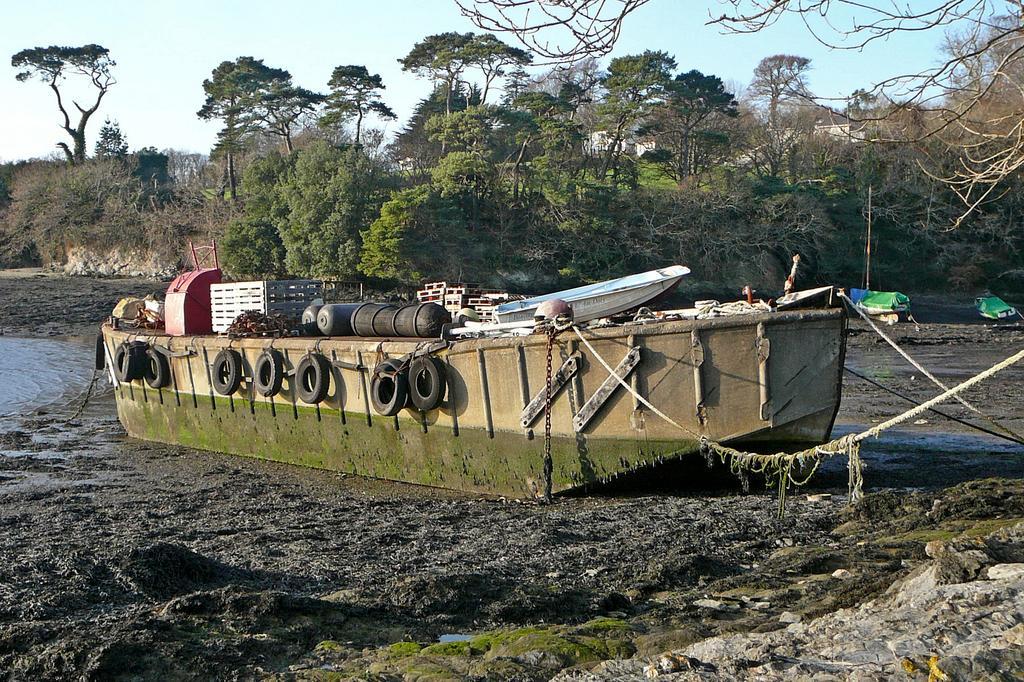Describe this image in one or two sentences. In the center of the image we can see one boat. On the boat, we can see tires, on wooden object, one chain and a few other objects. And we can see ropes are attached to the boat. At the bottom of the image we can see mud and stones. In the background, we can see the sky, trees, green color objects, water and a few other objects. 